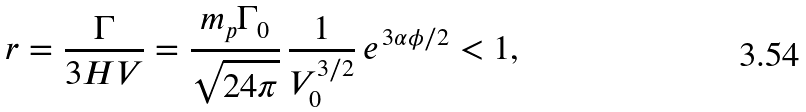<formula> <loc_0><loc_0><loc_500><loc_500>r = \frac { \Gamma } { 3 H V } = \frac { m _ { p } \Gamma _ { 0 } } { \sqrt { 2 4 \pi } } \, \frac { 1 } { V _ { 0 } ^ { 3 / 2 } } \, e ^ { \, 3 \alpha \phi / 2 } < 1 ,</formula> 